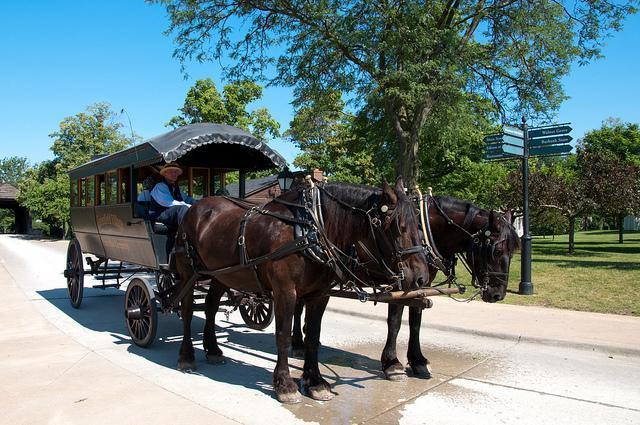How many horses can be seen?
Give a very brief answer. 2. 